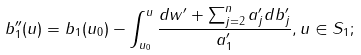Convert formula to latex. <formula><loc_0><loc_0><loc_500><loc_500>b _ { 1 } ^ { \prime \prime } ( u ) = b _ { 1 } ( u _ { 0 } ) - \int _ { u _ { 0 } } ^ { u } \frac { d w ^ { \prime } + \sum _ { j = 2 } ^ { n } a _ { j } ^ { \prime } d b _ { j } ^ { \prime } } { a _ { 1 } ^ { \prime } } , u \in S _ { 1 } ;</formula> 